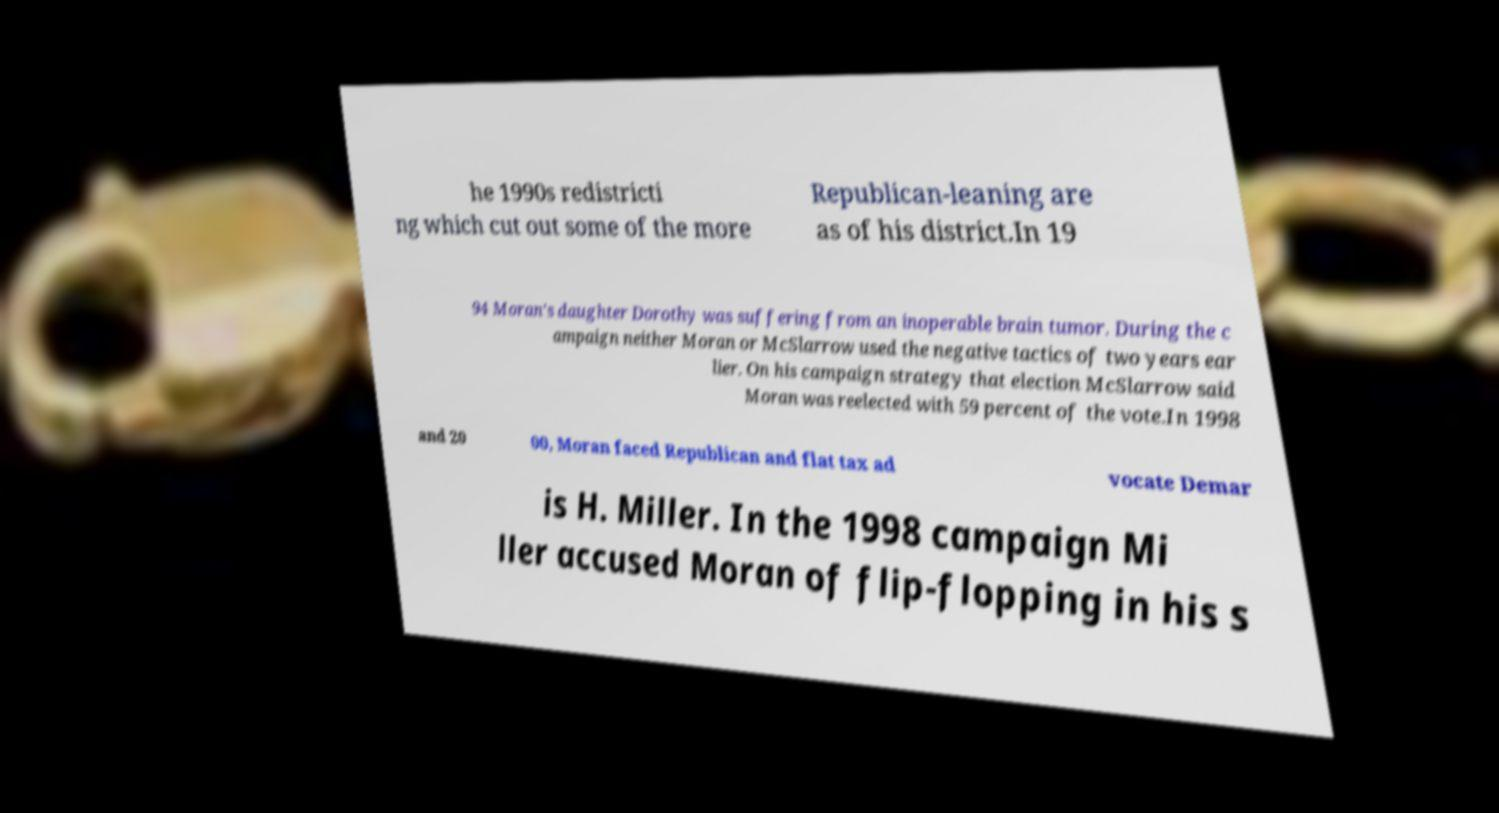There's text embedded in this image that I need extracted. Can you transcribe it verbatim? he 1990s redistricti ng which cut out some of the more Republican-leaning are as of his district.In 19 94 Moran's daughter Dorothy was suffering from an inoperable brain tumor. During the c ampaign neither Moran or McSlarrow used the negative tactics of two years ear lier. On his campaign strategy that election McSlarrow said Moran was reelected with 59 percent of the vote.In 1998 and 20 00, Moran faced Republican and flat tax ad vocate Demar is H. Miller. In the 1998 campaign Mi ller accused Moran of flip-flopping in his s 